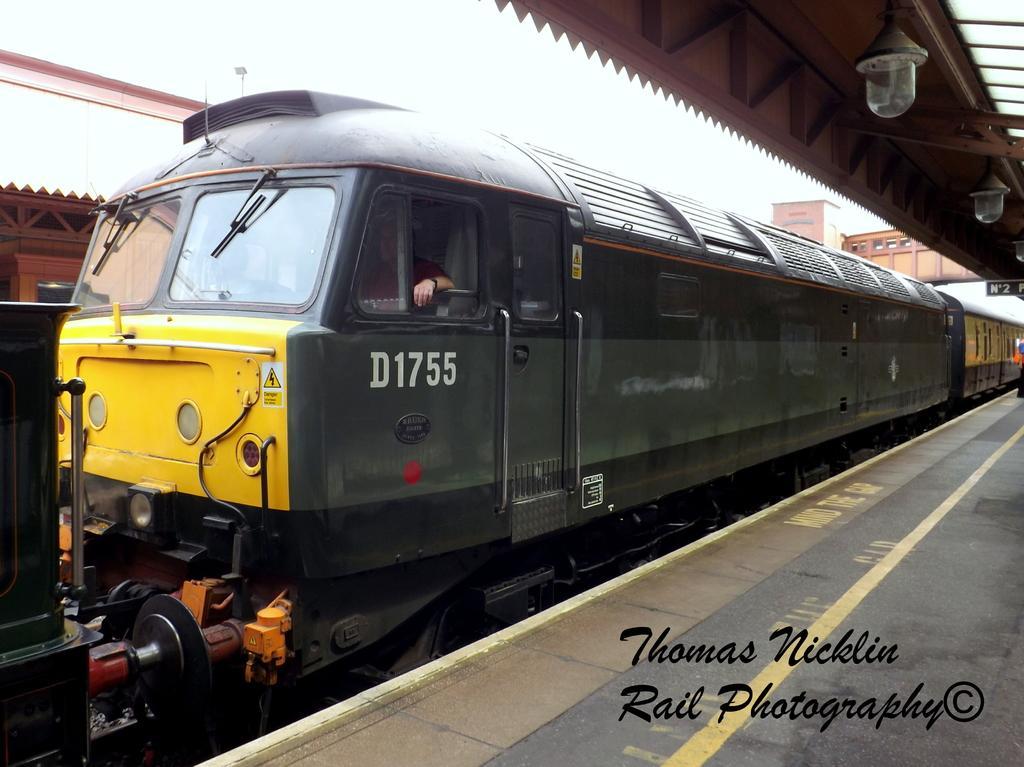How would you summarize this image in a sentence or two? In this picture we can observe a train moving on the railway track. The train is in green color. We can observe a platform on the right side. There are some lights hanging here. In the background there is a foot over bridge and a sky. 